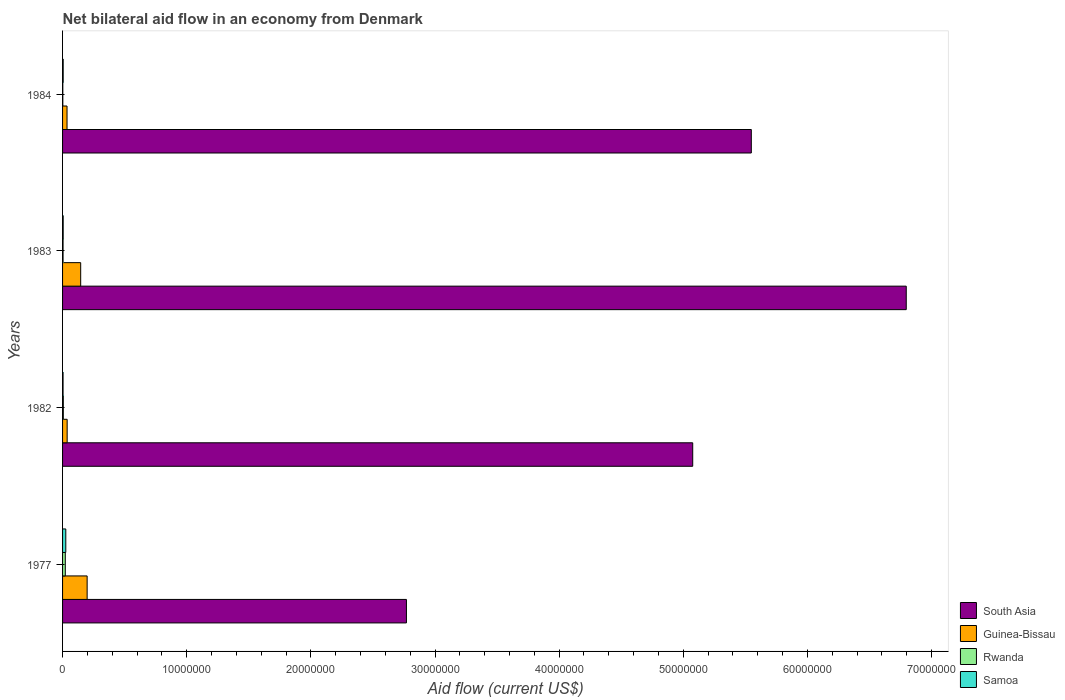How many groups of bars are there?
Your answer should be very brief. 4. Are the number of bars per tick equal to the number of legend labels?
Provide a short and direct response. Yes. Are the number of bars on each tick of the Y-axis equal?
Make the answer very short. Yes. How many bars are there on the 3rd tick from the bottom?
Ensure brevity in your answer.  4. What is the label of the 4th group of bars from the top?
Ensure brevity in your answer.  1977. In how many cases, is the number of bars for a given year not equal to the number of legend labels?
Offer a terse response. 0. Across all years, what is the minimum net bilateral aid flow in South Asia?
Offer a very short reply. 2.77e+07. In which year was the net bilateral aid flow in Samoa maximum?
Provide a succinct answer. 1977. In which year was the net bilateral aid flow in South Asia minimum?
Offer a very short reply. 1977. What is the total net bilateral aid flow in South Asia in the graph?
Provide a short and direct response. 2.02e+08. What is the difference between the net bilateral aid flow in Rwanda in 1977 and that in 1984?
Offer a very short reply. 2.00e+05. What is the difference between the net bilateral aid flow in Samoa in 1977 and the net bilateral aid flow in South Asia in 1982?
Provide a succinct answer. -5.05e+07. What is the average net bilateral aid flow in Rwanda per year?
Your answer should be very brief. 8.50e+04. In the year 1982, what is the difference between the net bilateral aid flow in South Asia and net bilateral aid flow in Samoa?
Make the answer very short. 5.07e+07. In how many years, is the net bilateral aid flow in Samoa greater than 48000000 US$?
Provide a short and direct response. 0. What is the ratio of the net bilateral aid flow in South Asia in 1977 to that in 1983?
Give a very brief answer. 0.41. What is the difference between the highest and the second highest net bilateral aid flow in Guinea-Bissau?
Your answer should be compact. 5.20e+05. What is the difference between the highest and the lowest net bilateral aid flow in South Asia?
Your answer should be compact. 4.03e+07. In how many years, is the net bilateral aid flow in Samoa greater than the average net bilateral aid flow in Samoa taken over all years?
Offer a terse response. 1. What does the 1st bar from the top in 1984 represents?
Ensure brevity in your answer.  Samoa. What does the 2nd bar from the bottom in 1977 represents?
Give a very brief answer. Guinea-Bissau. Is it the case that in every year, the sum of the net bilateral aid flow in Guinea-Bissau and net bilateral aid flow in Rwanda is greater than the net bilateral aid flow in South Asia?
Make the answer very short. No. Are the values on the major ticks of X-axis written in scientific E-notation?
Provide a succinct answer. No. Does the graph contain any zero values?
Give a very brief answer. No. Does the graph contain grids?
Your response must be concise. No. How are the legend labels stacked?
Keep it short and to the point. Vertical. What is the title of the graph?
Keep it short and to the point. Net bilateral aid flow in an economy from Denmark. What is the label or title of the Y-axis?
Ensure brevity in your answer.  Years. What is the Aid flow (current US$) in South Asia in 1977?
Provide a short and direct response. 2.77e+07. What is the Aid flow (current US$) of Guinea-Bissau in 1977?
Make the answer very short. 1.98e+06. What is the Aid flow (current US$) of South Asia in 1982?
Keep it short and to the point. 5.08e+07. What is the Aid flow (current US$) in Guinea-Bissau in 1982?
Ensure brevity in your answer.  3.70e+05. What is the Aid flow (current US$) of South Asia in 1983?
Your answer should be compact. 6.80e+07. What is the Aid flow (current US$) of Guinea-Bissau in 1983?
Your response must be concise. 1.46e+06. What is the Aid flow (current US$) in South Asia in 1984?
Offer a very short reply. 5.55e+07. Across all years, what is the maximum Aid flow (current US$) of South Asia?
Offer a terse response. 6.80e+07. Across all years, what is the maximum Aid flow (current US$) in Guinea-Bissau?
Offer a terse response. 1.98e+06. Across all years, what is the minimum Aid flow (current US$) of South Asia?
Keep it short and to the point. 2.77e+07. Across all years, what is the minimum Aid flow (current US$) in Guinea-Bissau?
Provide a short and direct response. 3.60e+05. Across all years, what is the minimum Aid flow (current US$) of Rwanda?
Give a very brief answer. 2.00e+04. Across all years, what is the minimum Aid flow (current US$) of Samoa?
Keep it short and to the point. 4.00e+04. What is the total Aid flow (current US$) in South Asia in the graph?
Provide a succinct answer. 2.02e+08. What is the total Aid flow (current US$) of Guinea-Bissau in the graph?
Provide a short and direct response. 4.17e+06. What is the total Aid flow (current US$) of Rwanda in the graph?
Provide a succinct answer. 3.40e+05. What is the difference between the Aid flow (current US$) in South Asia in 1977 and that in 1982?
Your answer should be very brief. -2.31e+07. What is the difference between the Aid flow (current US$) in Guinea-Bissau in 1977 and that in 1982?
Give a very brief answer. 1.61e+06. What is the difference between the Aid flow (current US$) in Rwanda in 1977 and that in 1982?
Your answer should be compact. 1.60e+05. What is the difference between the Aid flow (current US$) in Samoa in 1977 and that in 1982?
Your response must be concise. 2.20e+05. What is the difference between the Aid flow (current US$) of South Asia in 1977 and that in 1983?
Your response must be concise. -4.03e+07. What is the difference between the Aid flow (current US$) of Guinea-Bissau in 1977 and that in 1983?
Keep it short and to the point. 5.20e+05. What is the difference between the Aid flow (current US$) of Rwanda in 1977 and that in 1983?
Offer a very short reply. 1.80e+05. What is the difference between the Aid flow (current US$) of South Asia in 1977 and that in 1984?
Provide a short and direct response. -2.78e+07. What is the difference between the Aid flow (current US$) of Guinea-Bissau in 1977 and that in 1984?
Your answer should be very brief. 1.62e+06. What is the difference between the Aid flow (current US$) in South Asia in 1982 and that in 1983?
Offer a very short reply. -1.72e+07. What is the difference between the Aid flow (current US$) of Guinea-Bissau in 1982 and that in 1983?
Offer a very short reply. -1.09e+06. What is the difference between the Aid flow (current US$) of Samoa in 1982 and that in 1983?
Provide a short and direct response. -10000. What is the difference between the Aid flow (current US$) of South Asia in 1982 and that in 1984?
Provide a succinct answer. -4.72e+06. What is the difference between the Aid flow (current US$) in Rwanda in 1982 and that in 1984?
Provide a succinct answer. 4.00e+04. What is the difference between the Aid flow (current US$) of Samoa in 1982 and that in 1984?
Ensure brevity in your answer.  -10000. What is the difference between the Aid flow (current US$) in South Asia in 1983 and that in 1984?
Offer a terse response. 1.25e+07. What is the difference between the Aid flow (current US$) of Guinea-Bissau in 1983 and that in 1984?
Your answer should be very brief. 1.10e+06. What is the difference between the Aid flow (current US$) of Rwanda in 1983 and that in 1984?
Offer a very short reply. 2.00e+04. What is the difference between the Aid flow (current US$) of South Asia in 1977 and the Aid flow (current US$) of Guinea-Bissau in 1982?
Give a very brief answer. 2.73e+07. What is the difference between the Aid flow (current US$) in South Asia in 1977 and the Aid flow (current US$) in Rwanda in 1982?
Offer a very short reply. 2.76e+07. What is the difference between the Aid flow (current US$) in South Asia in 1977 and the Aid flow (current US$) in Samoa in 1982?
Provide a short and direct response. 2.77e+07. What is the difference between the Aid flow (current US$) in Guinea-Bissau in 1977 and the Aid flow (current US$) in Rwanda in 1982?
Make the answer very short. 1.92e+06. What is the difference between the Aid flow (current US$) of Guinea-Bissau in 1977 and the Aid flow (current US$) of Samoa in 1982?
Your answer should be compact. 1.94e+06. What is the difference between the Aid flow (current US$) in Rwanda in 1977 and the Aid flow (current US$) in Samoa in 1982?
Offer a very short reply. 1.80e+05. What is the difference between the Aid flow (current US$) in South Asia in 1977 and the Aid flow (current US$) in Guinea-Bissau in 1983?
Make the answer very short. 2.62e+07. What is the difference between the Aid flow (current US$) in South Asia in 1977 and the Aid flow (current US$) in Rwanda in 1983?
Make the answer very short. 2.77e+07. What is the difference between the Aid flow (current US$) in South Asia in 1977 and the Aid flow (current US$) in Samoa in 1983?
Provide a short and direct response. 2.76e+07. What is the difference between the Aid flow (current US$) of Guinea-Bissau in 1977 and the Aid flow (current US$) of Rwanda in 1983?
Ensure brevity in your answer.  1.94e+06. What is the difference between the Aid flow (current US$) in Guinea-Bissau in 1977 and the Aid flow (current US$) in Samoa in 1983?
Your answer should be compact. 1.93e+06. What is the difference between the Aid flow (current US$) in South Asia in 1977 and the Aid flow (current US$) in Guinea-Bissau in 1984?
Your response must be concise. 2.73e+07. What is the difference between the Aid flow (current US$) in South Asia in 1977 and the Aid flow (current US$) in Rwanda in 1984?
Your response must be concise. 2.77e+07. What is the difference between the Aid flow (current US$) of South Asia in 1977 and the Aid flow (current US$) of Samoa in 1984?
Provide a short and direct response. 2.76e+07. What is the difference between the Aid flow (current US$) in Guinea-Bissau in 1977 and the Aid flow (current US$) in Rwanda in 1984?
Offer a very short reply. 1.96e+06. What is the difference between the Aid flow (current US$) of Guinea-Bissau in 1977 and the Aid flow (current US$) of Samoa in 1984?
Provide a short and direct response. 1.93e+06. What is the difference between the Aid flow (current US$) of South Asia in 1982 and the Aid flow (current US$) of Guinea-Bissau in 1983?
Give a very brief answer. 4.93e+07. What is the difference between the Aid flow (current US$) of South Asia in 1982 and the Aid flow (current US$) of Rwanda in 1983?
Ensure brevity in your answer.  5.07e+07. What is the difference between the Aid flow (current US$) of South Asia in 1982 and the Aid flow (current US$) of Samoa in 1983?
Provide a short and direct response. 5.07e+07. What is the difference between the Aid flow (current US$) in Guinea-Bissau in 1982 and the Aid flow (current US$) in Samoa in 1983?
Ensure brevity in your answer.  3.20e+05. What is the difference between the Aid flow (current US$) of Rwanda in 1982 and the Aid flow (current US$) of Samoa in 1983?
Offer a very short reply. 10000. What is the difference between the Aid flow (current US$) in South Asia in 1982 and the Aid flow (current US$) in Guinea-Bissau in 1984?
Provide a succinct answer. 5.04e+07. What is the difference between the Aid flow (current US$) of South Asia in 1982 and the Aid flow (current US$) of Rwanda in 1984?
Your answer should be compact. 5.07e+07. What is the difference between the Aid flow (current US$) in South Asia in 1982 and the Aid flow (current US$) in Samoa in 1984?
Provide a short and direct response. 5.07e+07. What is the difference between the Aid flow (current US$) in Guinea-Bissau in 1982 and the Aid flow (current US$) in Rwanda in 1984?
Ensure brevity in your answer.  3.50e+05. What is the difference between the Aid flow (current US$) of Rwanda in 1982 and the Aid flow (current US$) of Samoa in 1984?
Your answer should be compact. 10000. What is the difference between the Aid flow (current US$) in South Asia in 1983 and the Aid flow (current US$) in Guinea-Bissau in 1984?
Your answer should be very brief. 6.76e+07. What is the difference between the Aid flow (current US$) of South Asia in 1983 and the Aid flow (current US$) of Rwanda in 1984?
Give a very brief answer. 6.79e+07. What is the difference between the Aid flow (current US$) in South Asia in 1983 and the Aid flow (current US$) in Samoa in 1984?
Provide a succinct answer. 6.79e+07. What is the difference between the Aid flow (current US$) of Guinea-Bissau in 1983 and the Aid flow (current US$) of Rwanda in 1984?
Offer a terse response. 1.44e+06. What is the difference between the Aid flow (current US$) of Guinea-Bissau in 1983 and the Aid flow (current US$) of Samoa in 1984?
Provide a short and direct response. 1.41e+06. What is the average Aid flow (current US$) in South Asia per year?
Your response must be concise. 5.05e+07. What is the average Aid flow (current US$) in Guinea-Bissau per year?
Give a very brief answer. 1.04e+06. What is the average Aid flow (current US$) in Rwanda per year?
Your response must be concise. 8.50e+04. What is the average Aid flow (current US$) in Samoa per year?
Keep it short and to the point. 1.00e+05. In the year 1977, what is the difference between the Aid flow (current US$) in South Asia and Aid flow (current US$) in Guinea-Bissau?
Keep it short and to the point. 2.57e+07. In the year 1977, what is the difference between the Aid flow (current US$) of South Asia and Aid flow (current US$) of Rwanda?
Provide a short and direct response. 2.75e+07. In the year 1977, what is the difference between the Aid flow (current US$) of South Asia and Aid flow (current US$) of Samoa?
Keep it short and to the point. 2.74e+07. In the year 1977, what is the difference between the Aid flow (current US$) of Guinea-Bissau and Aid flow (current US$) of Rwanda?
Offer a very short reply. 1.76e+06. In the year 1977, what is the difference between the Aid flow (current US$) in Guinea-Bissau and Aid flow (current US$) in Samoa?
Provide a succinct answer. 1.72e+06. In the year 1982, what is the difference between the Aid flow (current US$) in South Asia and Aid flow (current US$) in Guinea-Bissau?
Ensure brevity in your answer.  5.04e+07. In the year 1982, what is the difference between the Aid flow (current US$) in South Asia and Aid flow (current US$) in Rwanda?
Keep it short and to the point. 5.07e+07. In the year 1982, what is the difference between the Aid flow (current US$) of South Asia and Aid flow (current US$) of Samoa?
Your answer should be very brief. 5.07e+07. In the year 1982, what is the difference between the Aid flow (current US$) of Guinea-Bissau and Aid flow (current US$) of Samoa?
Ensure brevity in your answer.  3.30e+05. In the year 1983, what is the difference between the Aid flow (current US$) of South Asia and Aid flow (current US$) of Guinea-Bissau?
Your answer should be compact. 6.65e+07. In the year 1983, what is the difference between the Aid flow (current US$) in South Asia and Aid flow (current US$) in Rwanda?
Your answer should be compact. 6.79e+07. In the year 1983, what is the difference between the Aid flow (current US$) of South Asia and Aid flow (current US$) of Samoa?
Your response must be concise. 6.79e+07. In the year 1983, what is the difference between the Aid flow (current US$) of Guinea-Bissau and Aid flow (current US$) of Rwanda?
Your answer should be compact. 1.42e+06. In the year 1983, what is the difference between the Aid flow (current US$) of Guinea-Bissau and Aid flow (current US$) of Samoa?
Your answer should be compact. 1.41e+06. In the year 1983, what is the difference between the Aid flow (current US$) in Rwanda and Aid flow (current US$) in Samoa?
Offer a terse response. -10000. In the year 1984, what is the difference between the Aid flow (current US$) of South Asia and Aid flow (current US$) of Guinea-Bissau?
Your response must be concise. 5.51e+07. In the year 1984, what is the difference between the Aid flow (current US$) of South Asia and Aid flow (current US$) of Rwanda?
Your answer should be compact. 5.55e+07. In the year 1984, what is the difference between the Aid flow (current US$) of South Asia and Aid flow (current US$) of Samoa?
Your answer should be very brief. 5.54e+07. In the year 1984, what is the difference between the Aid flow (current US$) in Rwanda and Aid flow (current US$) in Samoa?
Your answer should be compact. -3.00e+04. What is the ratio of the Aid flow (current US$) in South Asia in 1977 to that in 1982?
Give a very brief answer. 0.55. What is the ratio of the Aid flow (current US$) in Guinea-Bissau in 1977 to that in 1982?
Give a very brief answer. 5.35. What is the ratio of the Aid flow (current US$) in Rwanda in 1977 to that in 1982?
Give a very brief answer. 3.67. What is the ratio of the Aid flow (current US$) of Samoa in 1977 to that in 1982?
Your response must be concise. 6.5. What is the ratio of the Aid flow (current US$) of South Asia in 1977 to that in 1983?
Keep it short and to the point. 0.41. What is the ratio of the Aid flow (current US$) of Guinea-Bissau in 1977 to that in 1983?
Provide a succinct answer. 1.36. What is the ratio of the Aid flow (current US$) in Samoa in 1977 to that in 1983?
Give a very brief answer. 5.2. What is the ratio of the Aid flow (current US$) in South Asia in 1977 to that in 1984?
Offer a very short reply. 0.5. What is the ratio of the Aid flow (current US$) of Guinea-Bissau in 1977 to that in 1984?
Give a very brief answer. 5.5. What is the ratio of the Aid flow (current US$) of South Asia in 1982 to that in 1983?
Your answer should be compact. 0.75. What is the ratio of the Aid flow (current US$) of Guinea-Bissau in 1982 to that in 1983?
Provide a succinct answer. 0.25. What is the ratio of the Aid flow (current US$) of Rwanda in 1982 to that in 1983?
Ensure brevity in your answer.  1.5. What is the ratio of the Aid flow (current US$) of South Asia in 1982 to that in 1984?
Offer a terse response. 0.91. What is the ratio of the Aid flow (current US$) in Guinea-Bissau in 1982 to that in 1984?
Provide a succinct answer. 1.03. What is the ratio of the Aid flow (current US$) in Samoa in 1982 to that in 1984?
Make the answer very short. 0.8. What is the ratio of the Aid flow (current US$) in South Asia in 1983 to that in 1984?
Make the answer very short. 1.22. What is the ratio of the Aid flow (current US$) of Guinea-Bissau in 1983 to that in 1984?
Your answer should be compact. 4.06. What is the ratio of the Aid flow (current US$) of Rwanda in 1983 to that in 1984?
Your response must be concise. 2. What is the difference between the highest and the second highest Aid flow (current US$) of South Asia?
Make the answer very short. 1.25e+07. What is the difference between the highest and the second highest Aid flow (current US$) of Guinea-Bissau?
Your response must be concise. 5.20e+05. What is the difference between the highest and the lowest Aid flow (current US$) of South Asia?
Your answer should be very brief. 4.03e+07. What is the difference between the highest and the lowest Aid flow (current US$) of Guinea-Bissau?
Ensure brevity in your answer.  1.62e+06. What is the difference between the highest and the lowest Aid flow (current US$) in Samoa?
Ensure brevity in your answer.  2.20e+05. 